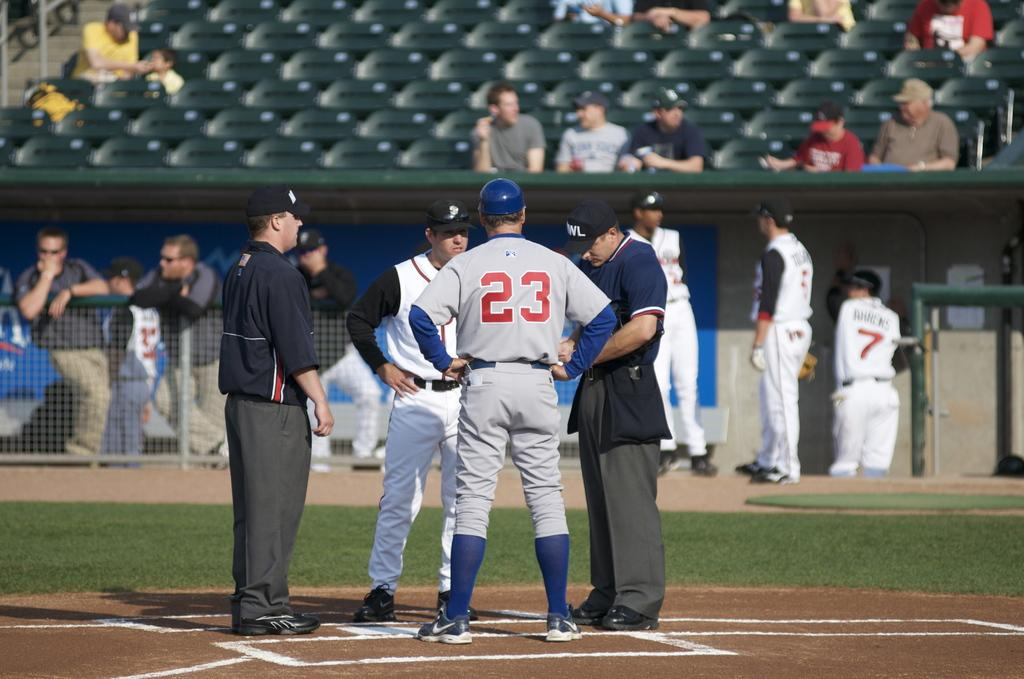<image>
Relay a brief, clear account of the picture shown. Baseball player with number 23 stands on the mound next to two umpires. 